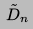Convert formula to latex. <formula><loc_0><loc_0><loc_500><loc_500>\tilde { D } _ { n }</formula> 